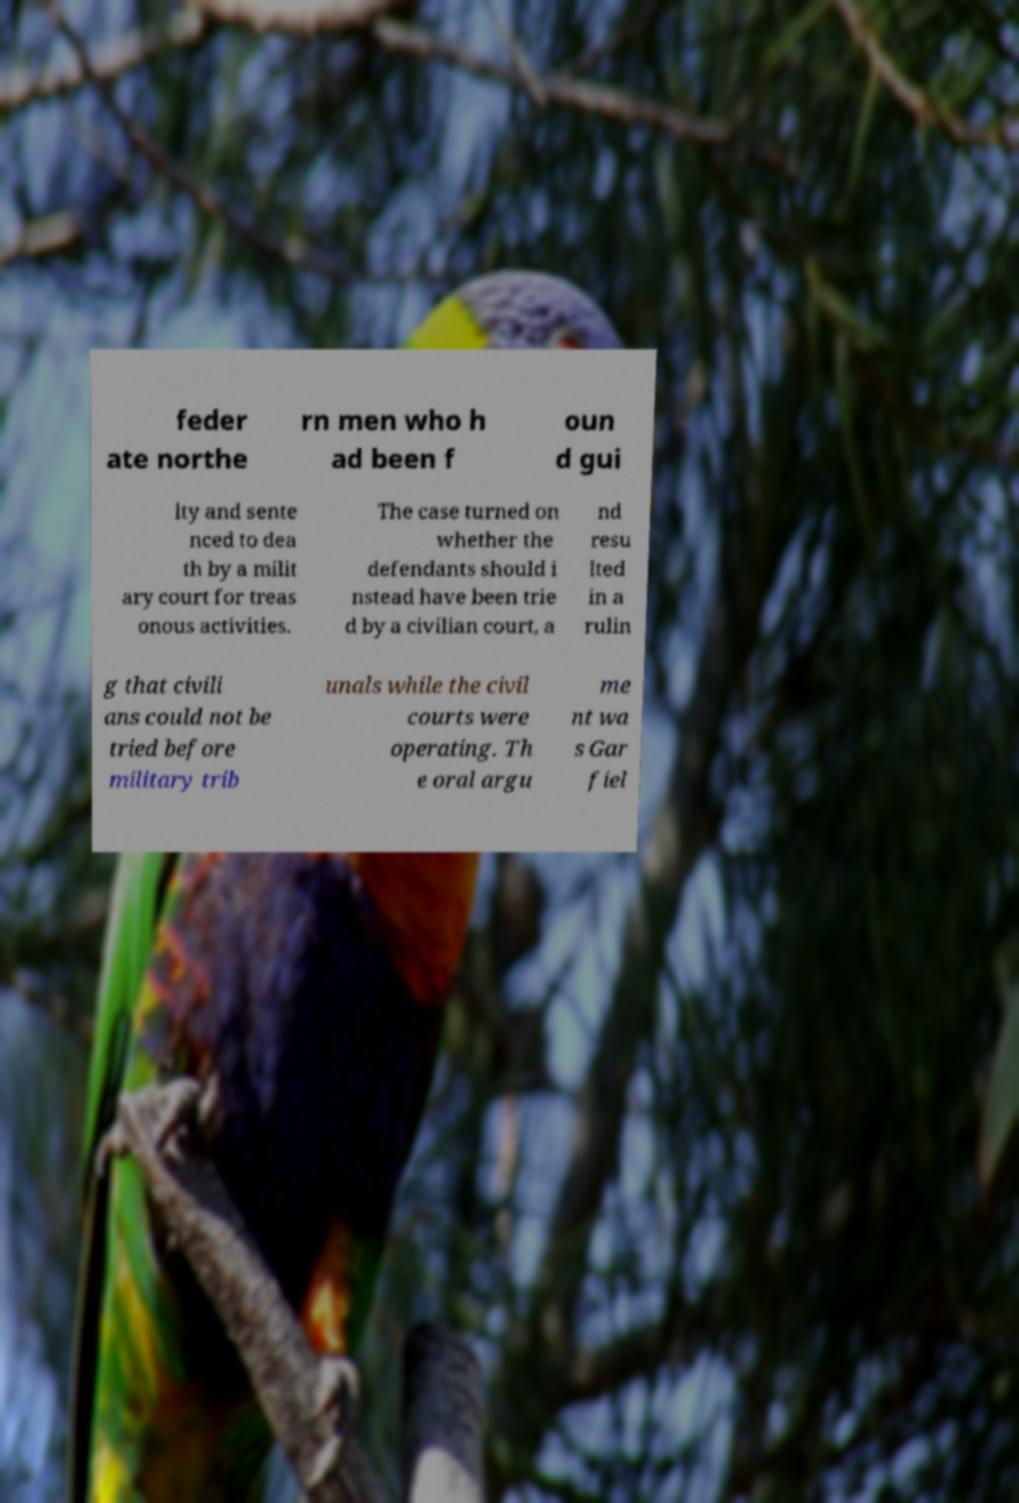There's text embedded in this image that I need extracted. Can you transcribe it verbatim? feder ate northe rn men who h ad been f oun d gui lty and sente nced to dea th by a milit ary court for treas onous activities. The case turned on whether the defendants should i nstead have been trie d by a civilian court, a nd resu lted in a rulin g that civili ans could not be tried before military trib unals while the civil courts were operating. Th e oral argu me nt wa s Gar fiel 